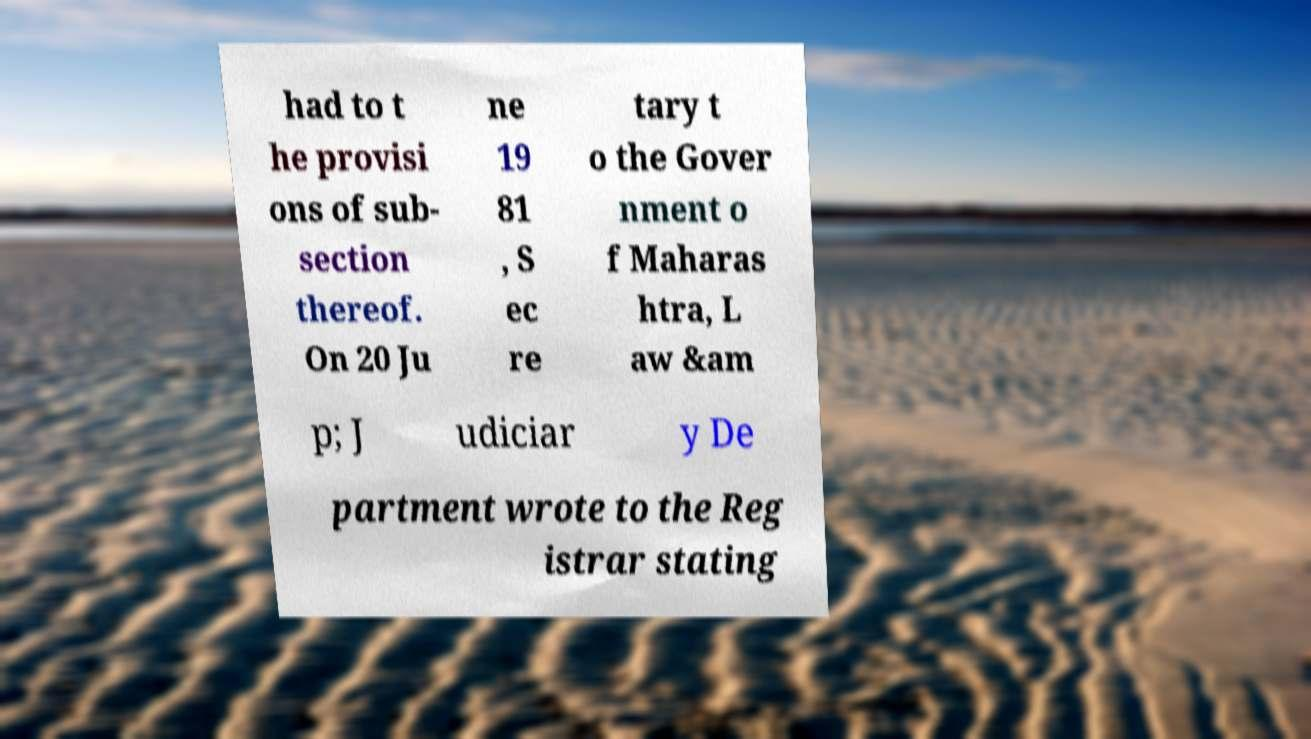Could you assist in decoding the text presented in this image and type it out clearly? had to t he provisi ons of sub- section thereof. On 20 Ju ne 19 81 , S ec re tary t o the Gover nment o f Maharas htra, L aw &am p; J udiciar y De partment wrote to the Reg istrar stating 